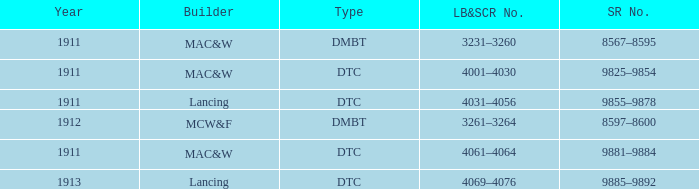What is the lb&scr number corresponding to the sr number 8597-8600? 3261–3264. 